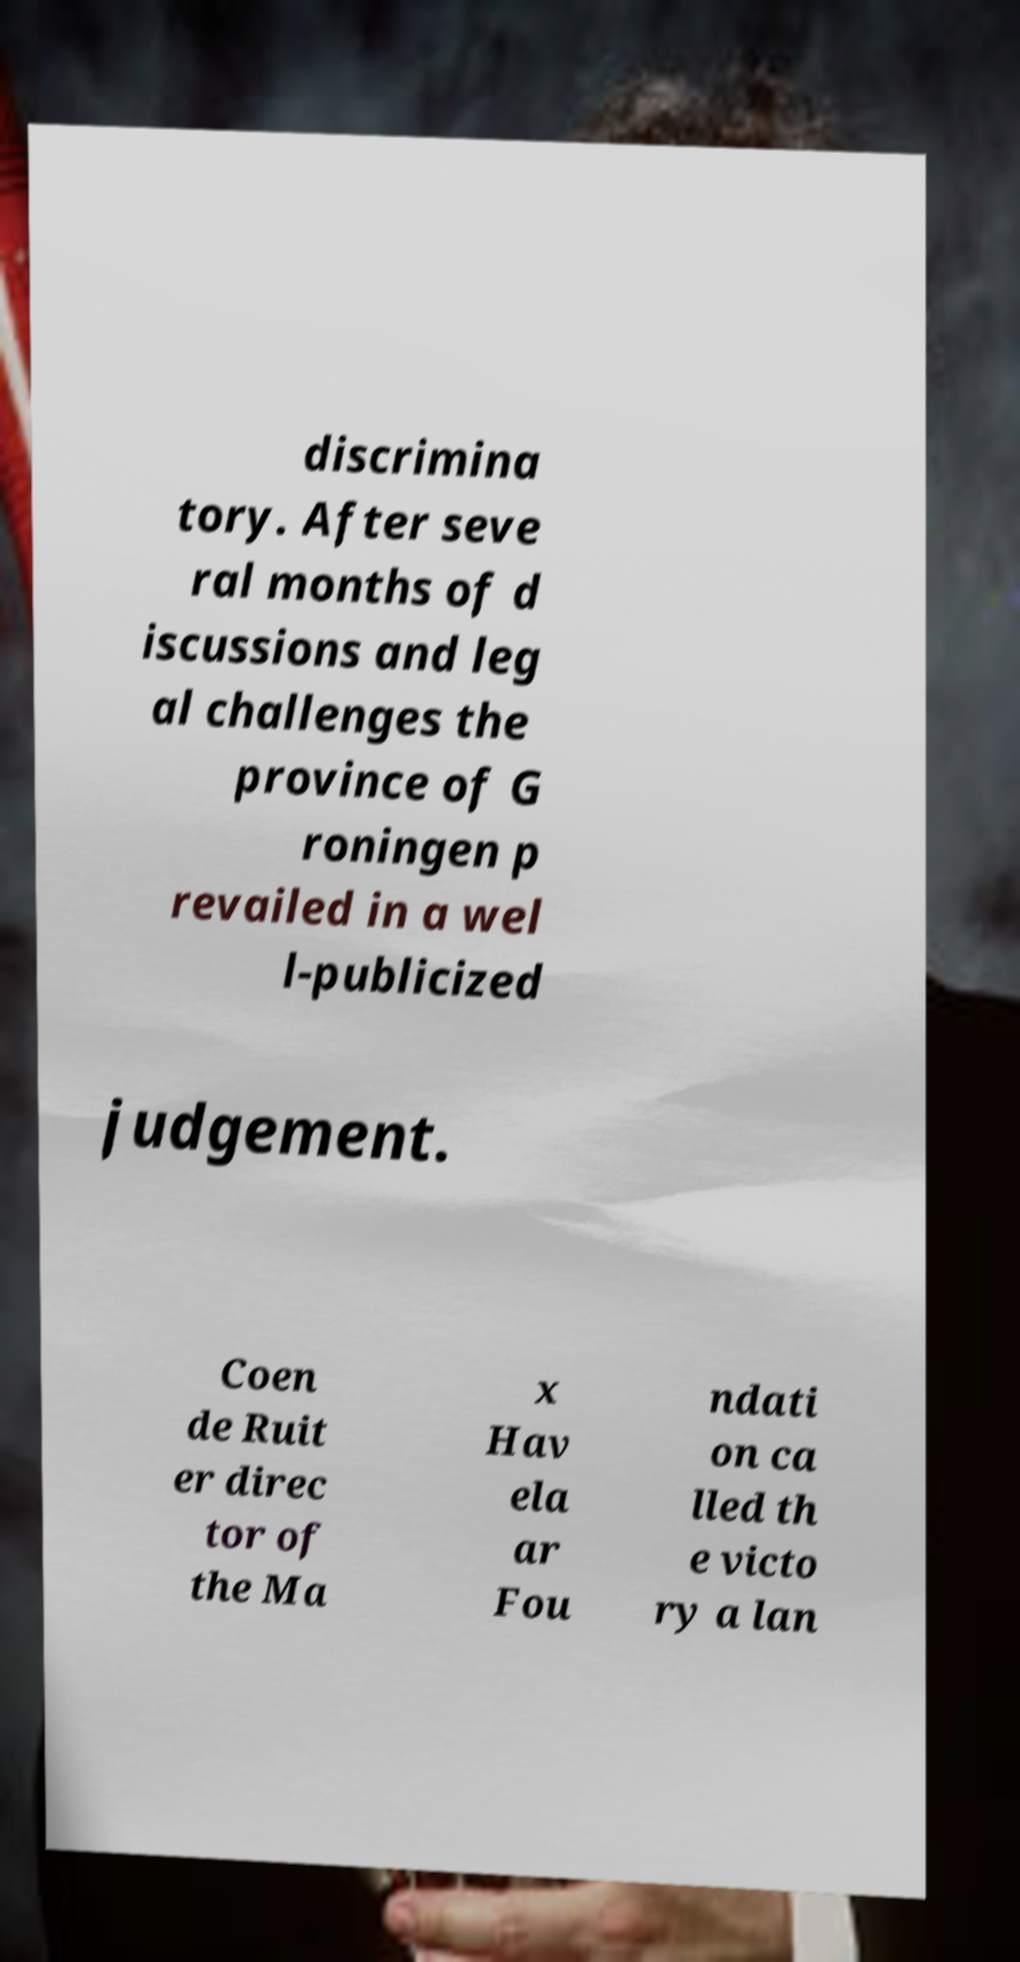Can you read and provide the text displayed in the image?This photo seems to have some interesting text. Can you extract and type it out for me? discrimina tory. After seve ral months of d iscussions and leg al challenges the province of G roningen p revailed in a wel l-publicized judgement. Coen de Ruit er direc tor of the Ma x Hav ela ar Fou ndati on ca lled th e victo ry a lan 